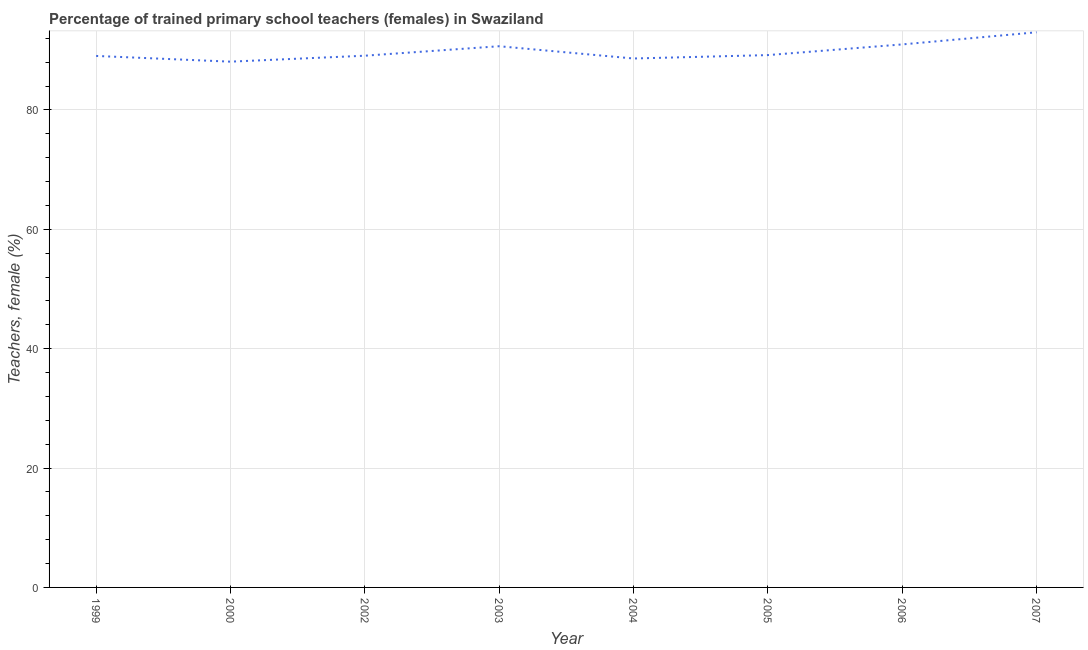What is the percentage of trained female teachers in 2004?
Your answer should be compact. 88.62. Across all years, what is the maximum percentage of trained female teachers?
Your response must be concise. 93.01. Across all years, what is the minimum percentage of trained female teachers?
Provide a succinct answer. 88.09. In which year was the percentage of trained female teachers maximum?
Provide a short and direct response. 2007. In which year was the percentage of trained female teachers minimum?
Your answer should be very brief. 2000. What is the sum of the percentage of trained female teachers?
Ensure brevity in your answer.  718.72. What is the difference between the percentage of trained female teachers in 2000 and 2007?
Your answer should be compact. -4.92. What is the average percentage of trained female teachers per year?
Ensure brevity in your answer.  89.84. What is the median percentage of trained female teachers?
Offer a very short reply. 89.14. Do a majority of the years between 2000 and 2005 (inclusive) have percentage of trained female teachers greater than 20 %?
Your response must be concise. Yes. What is the ratio of the percentage of trained female teachers in 2000 to that in 2004?
Give a very brief answer. 0.99. Is the percentage of trained female teachers in 2004 less than that in 2006?
Your answer should be very brief. Yes. What is the difference between the highest and the second highest percentage of trained female teachers?
Give a very brief answer. 2.03. Is the sum of the percentage of trained female teachers in 2000 and 2004 greater than the maximum percentage of trained female teachers across all years?
Your response must be concise. Yes. What is the difference between the highest and the lowest percentage of trained female teachers?
Provide a succinct answer. 4.92. In how many years, is the percentage of trained female teachers greater than the average percentage of trained female teachers taken over all years?
Provide a succinct answer. 3. Does the percentage of trained female teachers monotonically increase over the years?
Offer a very short reply. No. How many lines are there?
Give a very brief answer. 1. How many years are there in the graph?
Provide a succinct answer. 8. Are the values on the major ticks of Y-axis written in scientific E-notation?
Your answer should be compact. No. Does the graph contain any zero values?
Ensure brevity in your answer.  No. Does the graph contain grids?
Offer a very short reply. Yes. What is the title of the graph?
Make the answer very short. Percentage of trained primary school teachers (females) in Swaziland. What is the label or title of the Y-axis?
Make the answer very short. Teachers, female (%). What is the Teachers, female (%) in 1999?
Your response must be concise. 89.05. What is the Teachers, female (%) in 2000?
Provide a succinct answer. 88.09. What is the Teachers, female (%) in 2002?
Your answer should be very brief. 89.09. What is the Teachers, female (%) in 2003?
Offer a very short reply. 90.68. What is the Teachers, female (%) of 2004?
Provide a short and direct response. 88.62. What is the Teachers, female (%) in 2005?
Provide a succinct answer. 89.19. What is the Teachers, female (%) in 2006?
Keep it short and to the point. 90.98. What is the Teachers, female (%) in 2007?
Your answer should be very brief. 93.01. What is the difference between the Teachers, female (%) in 1999 and 2000?
Your answer should be compact. 0.96. What is the difference between the Teachers, female (%) in 1999 and 2002?
Give a very brief answer. -0.04. What is the difference between the Teachers, female (%) in 1999 and 2003?
Your response must be concise. -1.63. What is the difference between the Teachers, female (%) in 1999 and 2004?
Your answer should be compact. 0.43. What is the difference between the Teachers, female (%) in 1999 and 2005?
Your response must be concise. -0.14. What is the difference between the Teachers, female (%) in 1999 and 2006?
Make the answer very short. -1.93. What is the difference between the Teachers, female (%) in 1999 and 2007?
Provide a short and direct response. -3.96. What is the difference between the Teachers, female (%) in 2000 and 2002?
Provide a succinct answer. -1. What is the difference between the Teachers, female (%) in 2000 and 2003?
Your answer should be very brief. -2.58. What is the difference between the Teachers, female (%) in 2000 and 2004?
Your answer should be compact. -0.53. What is the difference between the Teachers, female (%) in 2000 and 2005?
Provide a short and direct response. -1.1. What is the difference between the Teachers, female (%) in 2000 and 2006?
Ensure brevity in your answer.  -2.89. What is the difference between the Teachers, female (%) in 2000 and 2007?
Offer a terse response. -4.92. What is the difference between the Teachers, female (%) in 2002 and 2003?
Provide a succinct answer. -1.59. What is the difference between the Teachers, female (%) in 2002 and 2004?
Offer a terse response. 0.47. What is the difference between the Teachers, female (%) in 2002 and 2005?
Provide a short and direct response. -0.1. What is the difference between the Teachers, female (%) in 2002 and 2006?
Your answer should be very brief. -1.89. What is the difference between the Teachers, female (%) in 2002 and 2007?
Keep it short and to the point. -3.92. What is the difference between the Teachers, female (%) in 2003 and 2004?
Make the answer very short. 2.05. What is the difference between the Teachers, female (%) in 2003 and 2005?
Make the answer very short. 1.48. What is the difference between the Teachers, female (%) in 2003 and 2006?
Offer a terse response. -0.3. What is the difference between the Teachers, female (%) in 2003 and 2007?
Make the answer very short. -2.34. What is the difference between the Teachers, female (%) in 2004 and 2005?
Offer a very short reply. -0.57. What is the difference between the Teachers, female (%) in 2004 and 2006?
Give a very brief answer. -2.36. What is the difference between the Teachers, female (%) in 2004 and 2007?
Give a very brief answer. -4.39. What is the difference between the Teachers, female (%) in 2005 and 2006?
Your answer should be compact. -1.79. What is the difference between the Teachers, female (%) in 2005 and 2007?
Give a very brief answer. -3.82. What is the difference between the Teachers, female (%) in 2006 and 2007?
Ensure brevity in your answer.  -2.03. What is the ratio of the Teachers, female (%) in 1999 to that in 2004?
Offer a very short reply. 1. What is the ratio of the Teachers, female (%) in 1999 to that in 2005?
Provide a succinct answer. 1. What is the ratio of the Teachers, female (%) in 1999 to that in 2007?
Ensure brevity in your answer.  0.96. What is the ratio of the Teachers, female (%) in 2000 to that in 2003?
Keep it short and to the point. 0.97. What is the ratio of the Teachers, female (%) in 2000 to that in 2007?
Your answer should be compact. 0.95. What is the ratio of the Teachers, female (%) in 2002 to that in 2003?
Provide a succinct answer. 0.98. What is the ratio of the Teachers, female (%) in 2002 to that in 2004?
Your response must be concise. 1. What is the ratio of the Teachers, female (%) in 2002 to that in 2005?
Offer a very short reply. 1. What is the ratio of the Teachers, female (%) in 2002 to that in 2007?
Offer a very short reply. 0.96. What is the ratio of the Teachers, female (%) in 2003 to that in 2006?
Your response must be concise. 1. What is the ratio of the Teachers, female (%) in 2003 to that in 2007?
Ensure brevity in your answer.  0.97. What is the ratio of the Teachers, female (%) in 2004 to that in 2007?
Ensure brevity in your answer.  0.95. What is the ratio of the Teachers, female (%) in 2005 to that in 2007?
Provide a succinct answer. 0.96. 